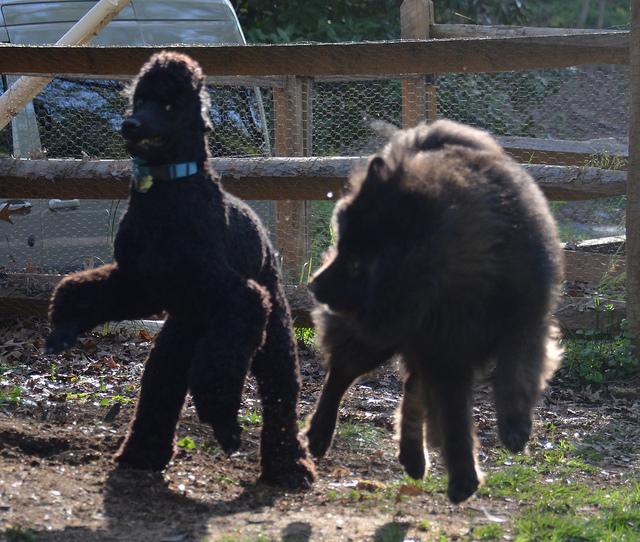What color is the dog?
Quick response, please. Black. Is the dog brown?
Write a very short answer. Yes. Can you see the dog's eyes?
Quick response, please. Yes. What breed of dogs are these?
Be succinct. Poodle. Are both animals fully on the ground?
Answer briefly. No. What color is the animal on the right's fur?
Quick response, please. Brown. Is the dog dressed up?
Answer briefly. No. 